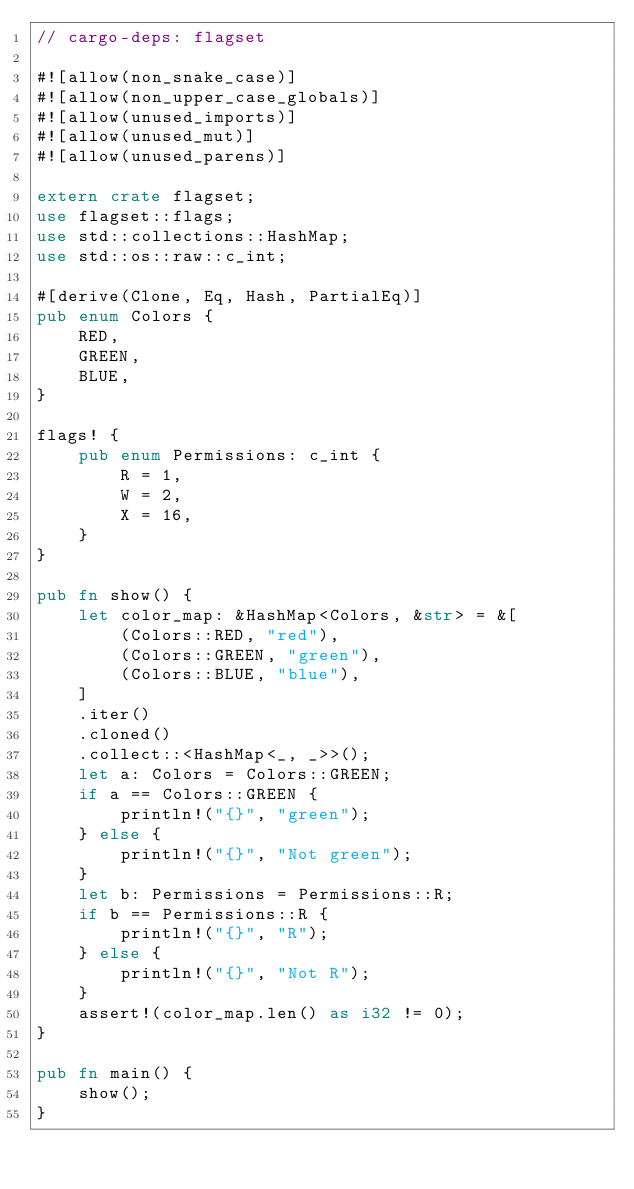Convert code to text. <code><loc_0><loc_0><loc_500><loc_500><_Rust_>// cargo-deps: flagset

#![allow(non_snake_case)]
#![allow(non_upper_case_globals)]
#![allow(unused_imports)]
#![allow(unused_mut)]
#![allow(unused_parens)]

extern crate flagset;
use flagset::flags;
use std::collections::HashMap;
use std::os::raw::c_int;

#[derive(Clone, Eq, Hash, PartialEq)]
pub enum Colors {
    RED,
    GREEN,
    BLUE,
}

flags! {
    pub enum Permissions: c_int {
        R = 1,
        W = 2,
        X = 16,
    }
}

pub fn show() {
    let color_map: &HashMap<Colors, &str> = &[
        (Colors::RED, "red"),
        (Colors::GREEN, "green"),
        (Colors::BLUE, "blue"),
    ]
    .iter()
    .cloned()
    .collect::<HashMap<_, _>>();
    let a: Colors = Colors::GREEN;
    if a == Colors::GREEN {
        println!("{}", "green");
    } else {
        println!("{}", "Not green");
    }
    let b: Permissions = Permissions::R;
    if b == Permissions::R {
        println!("{}", "R");
    } else {
        println!("{}", "Not R");
    }
    assert!(color_map.len() as i32 != 0);
}

pub fn main() {
    show();
}
</code> 